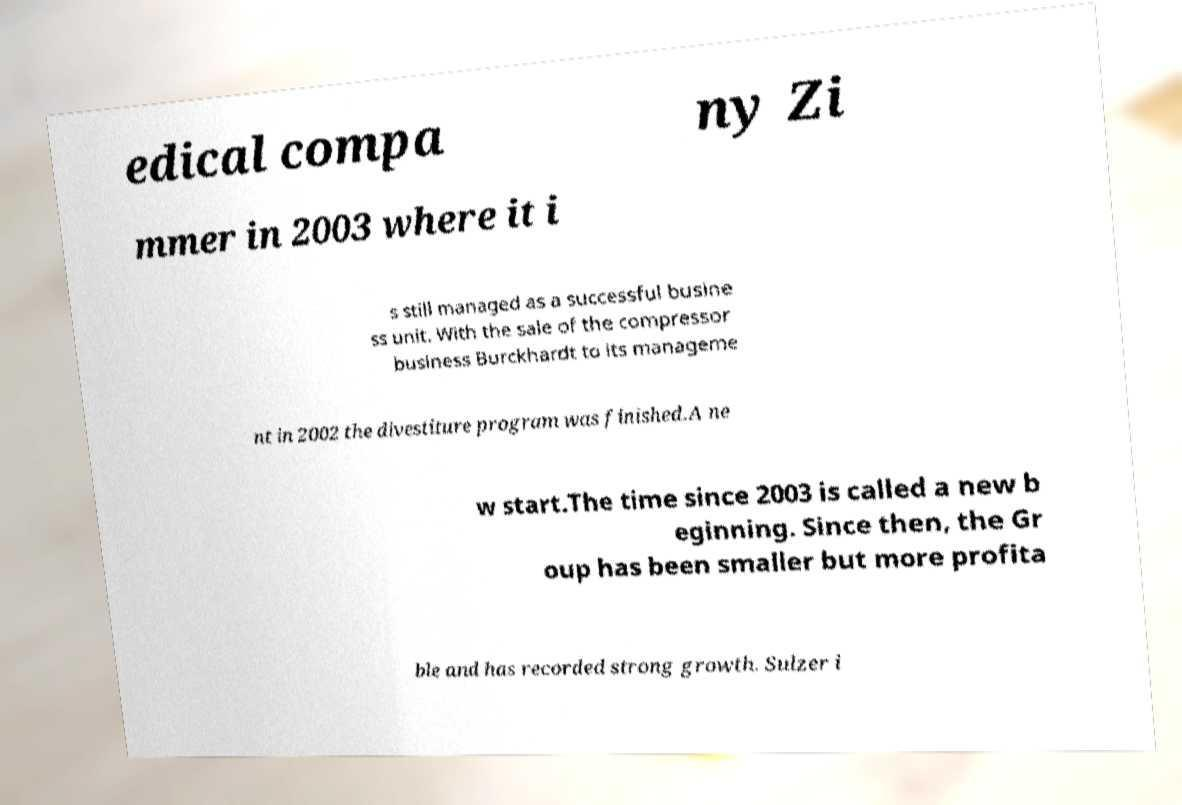Can you read and provide the text displayed in the image?This photo seems to have some interesting text. Can you extract and type it out for me? edical compa ny Zi mmer in 2003 where it i s still managed as a successful busine ss unit. With the sale of the compressor business Burckhardt to its manageme nt in 2002 the divestiture program was finished.A ne w start.The time since 2003 is called a new b eginning. Since then, the Gr oup has been smaller but more profita ble and has recorded strong growth. Sulzer i 